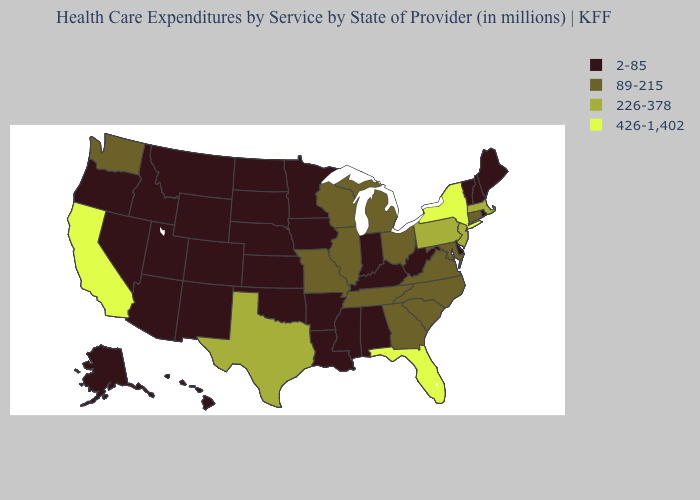What is the value of Minnesota?
Write a very short answer. 2-85. Which states hav the highest value in the MidWest?
Give a very brief answer. Illinois, Michigan, Missouri, Ohio, Wisconsin. What is the value of New Hampshire?
Answer briefly. 2-85. Does California have the highest value in the West?
Quick response, please. Yes. What is the value of Nevada?
Keep it brief. 2-85. Name the states that have a value in the range 426-1,402?
Concise answer only. California, Florida, New York. What is the highest value in the USA?
Write a very short answer. 426-1,402. Does Utah have the lowest value in the West?
Give a very brief answer. Yes. What is the value of Alabama?
Give a very brief answer. 2-85. What is the value of South Carolina?
Keep it brief. 89-215. What is the lowest value in states that border New Hampshire?
Quick response, please. 2-85. Name the states that have a value in the range 226-378?
Concise answer only. Massachusetts, New Jersey, Pennsylvania, Texas. Name the states that have a value in the range 426-1,402?
Keep it brief. California, Florida, New York. Which states hav the highest value in the Northeast?
Be succinct. New York. 